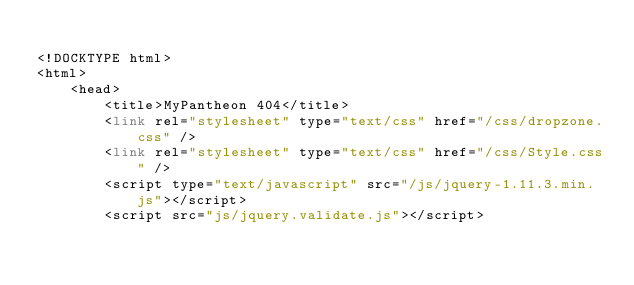Convert code to text. <code><loc_0><loc_0><loc_500><loc_500><_PHP_>
<!DOCKTYPE html>
<html>
    <head>
        <title>MyPantheon 404</title>
        <link rel="stylesheet" type="text/css" href="/css/dropzone.css" />
        <link rel="stylesheet" type="text/css" href="/css/Style.css" />
        <script type="text/javascript" src="/js/jquery-1.11.3.min.js"></script>
        <script src="js/jquery.validate.js"></script></code> 